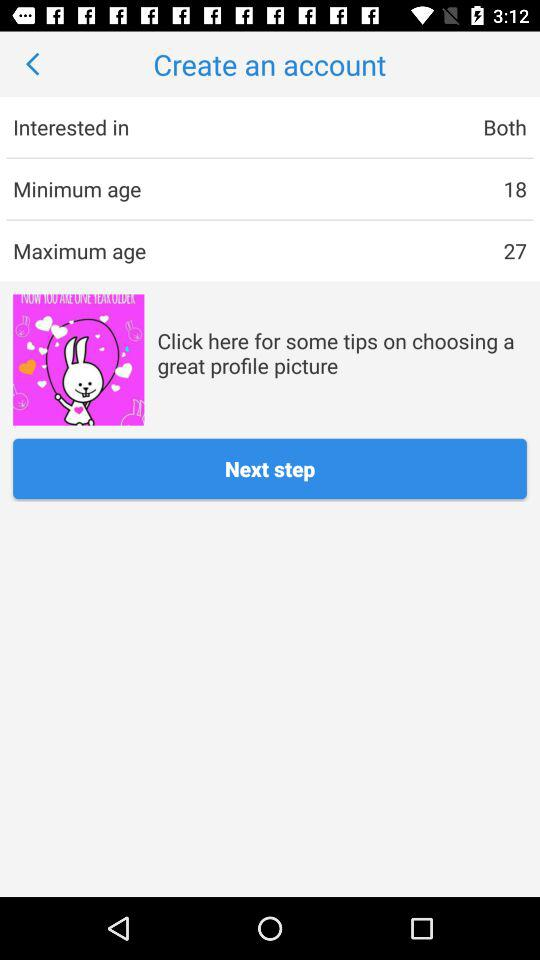What is the sum of the age ranges in the minimum age and maximum age fields?
Answer the question using a single word or phrase. 45 